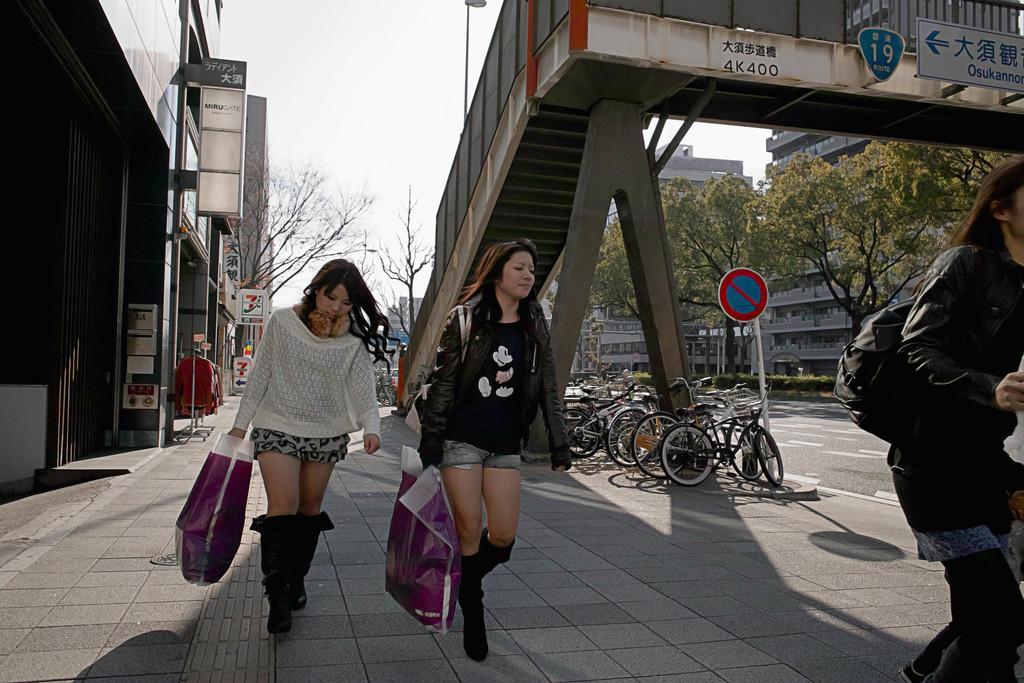Could you give a brief overview of what you see in this image? In this image we can see two women are walking and they are holding plastic bags with their hands. Here we can bicycles, poles, boards, plants, road, trees, clothes, and buildings. On the right side of the image we can see a woman who is truncated and she wore a bag. In the background there is sky. 